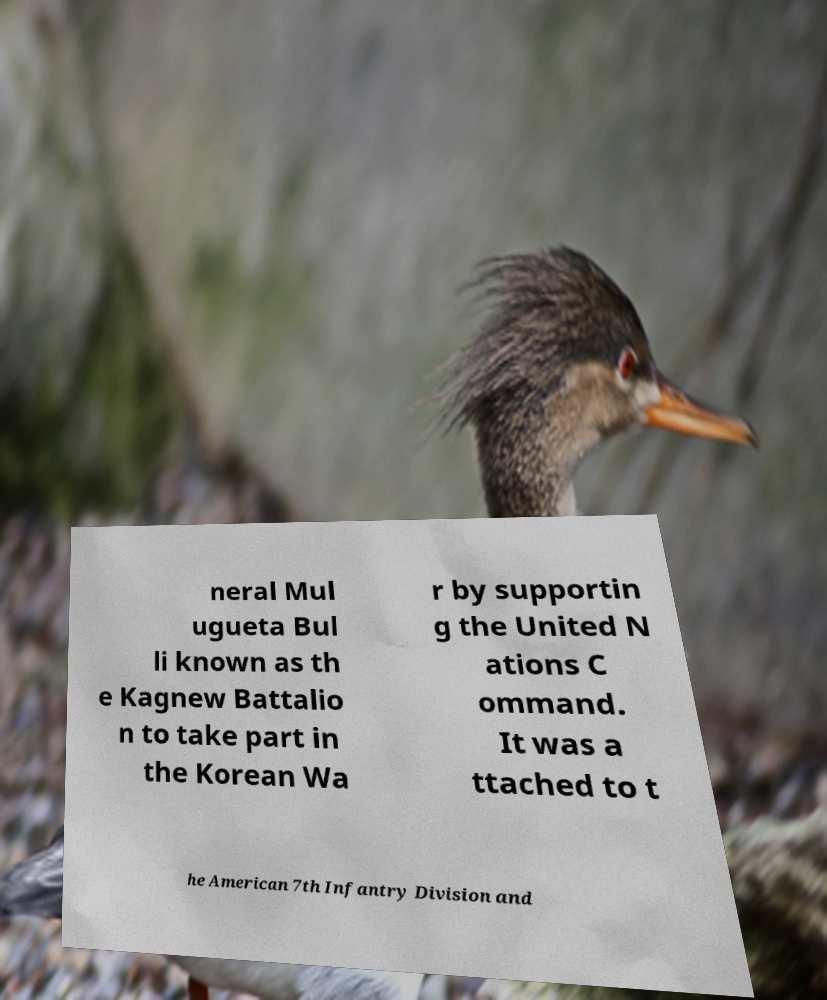Please identify and transcribe the text found in this image. neral Mul ugueta Bul li known as th e Kagnew Battalio n to take part in the Korean Wa r by supportin g the United N ations C ommand. It was a ttached to t he American 7th Infantry Division and 